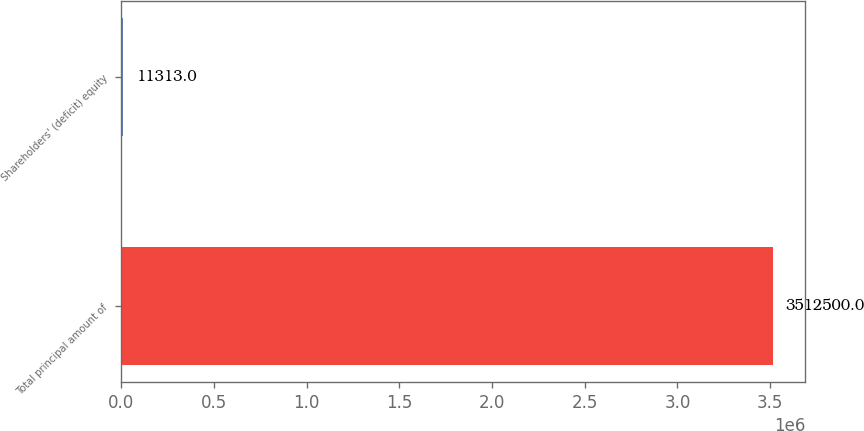<chart> <loc_0><loc_0><loc_500><loc_500><bar_chart><fcel>Total principal amount of<fcel>Shareholders' (deficit) equity<nl><fcel>3.5125e+06<fcel>11313<nl></chart> 